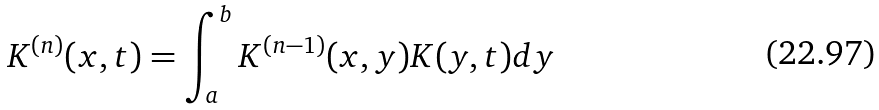Convert formula to latex. <formula><loc_0><loc_0><loc_500><loc_500>K ^ { ( n ) } ( x , t ) = \int _ { a } ^ { b } K ^ { ( n - 1 ) } ( x , y ) K ( y , t ) d y</formula> 